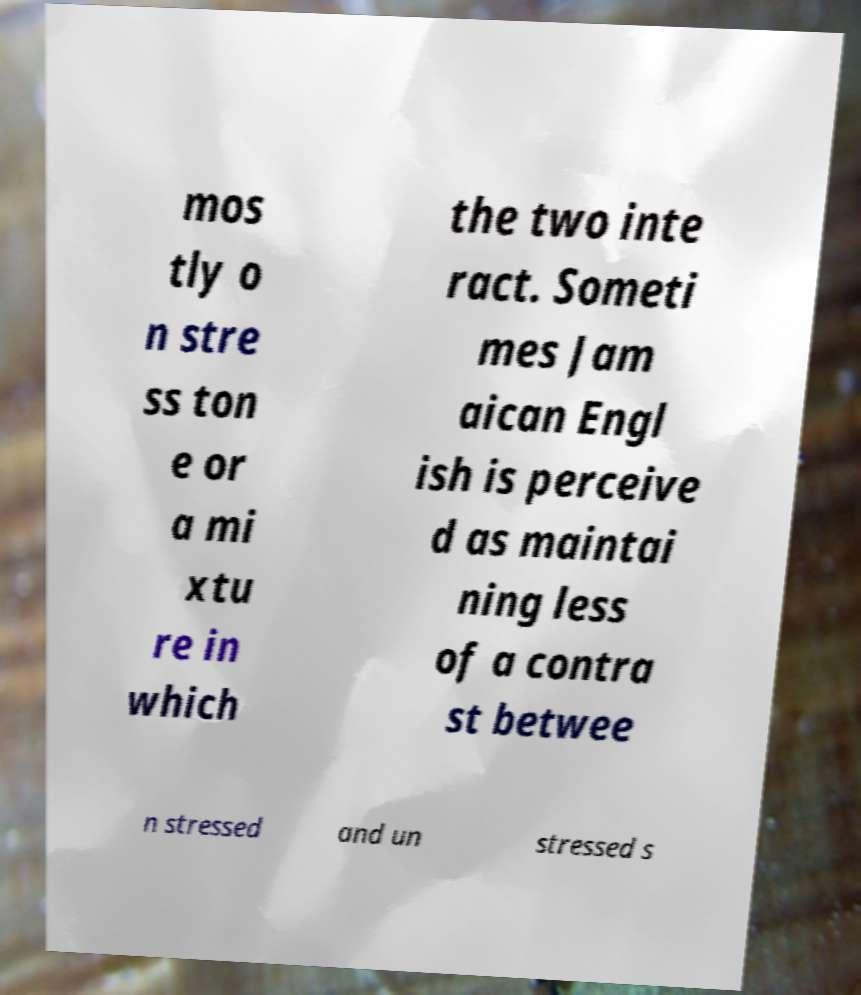I need the written content from this picture converted into text. Can you do that? mos tly o n stre ss ton e or a mi xtu re in which the two inte ract. Someti mes Jam aican Engl ish is perceive d as maintai ning less of a contra st betwee n stressed and un stressed s 